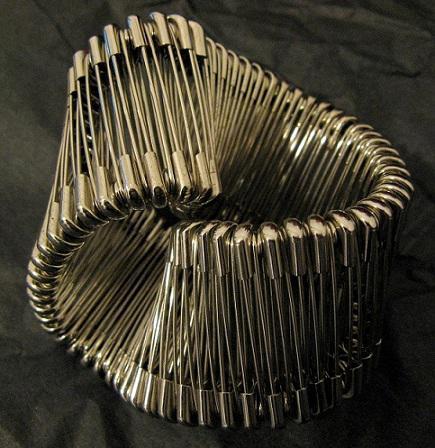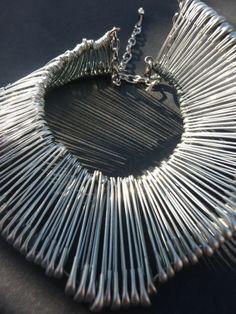The first image is the image on the left, the second image is the image on the right. For the images displayed, is the sentence "Two of the creations appear to be birds with outstretched wings." factually correct? Answer yes or no. No. The first image is the image on the left, the second image is the image on the right. Considering the images on both sides, is "An image shows an item made of pins displayed around the neck of something." valid? Answer yes or no. No. 